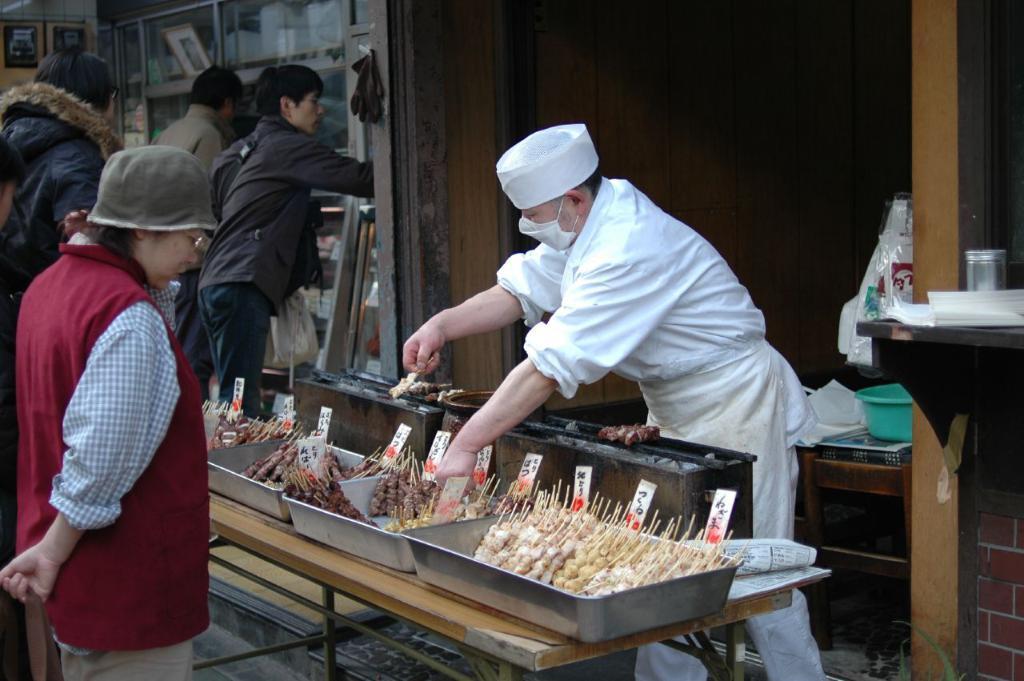In one or two sentences, can you explain what this image depicts? At the center of the image there is a food stall. On the right side of the image there is a person wearing a white dress. On the left side of the image there are two persons standing and looking for the food. In the background there are few persons. 